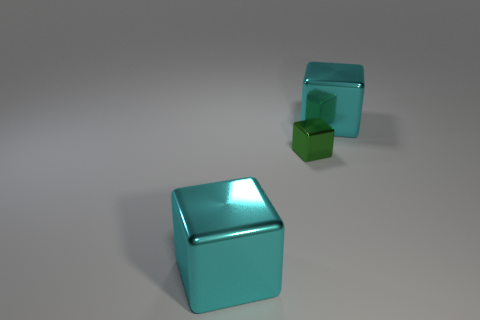Is the number of big cyan metallic objects on the left side of the small metallic object greater than the number of big cylinders?
Give a very brief answer. Yes. Is there a cyan shiny cube that is behind the metallic cube that is in front of the tiny shiny cube?
Offer a terse response. Yes. What is the cube that is to the right of the tiny green shiny cube made of?
Provide a succinct answer. Metal. Is the material of the large cyan thing that is behind the tiny shiny cube the same as the cyan cube that is to the left of the green metallic block?
Provide a short and direct response. Yes. How many cyan objects are the same material as the tiny green thing?
Offer a terse response. 2. There is a cyan shiny object that is in front of the large object that is behind the tiny green metallic cube; what is its size?
Give a very brief answer. Large. Are there the same number of green metallic cubes in front of the green cube and purple spheres?
Keep it short and to the point. Yes. Do the large cube that is behind the green cube and the small object have the same material?
Provide a short and direct response. Yes. What number of big objects are metallic things or green blocks?
Your answer should be very brief. 2. What size is the green shiny block?
Offer a very short reply. Small. 